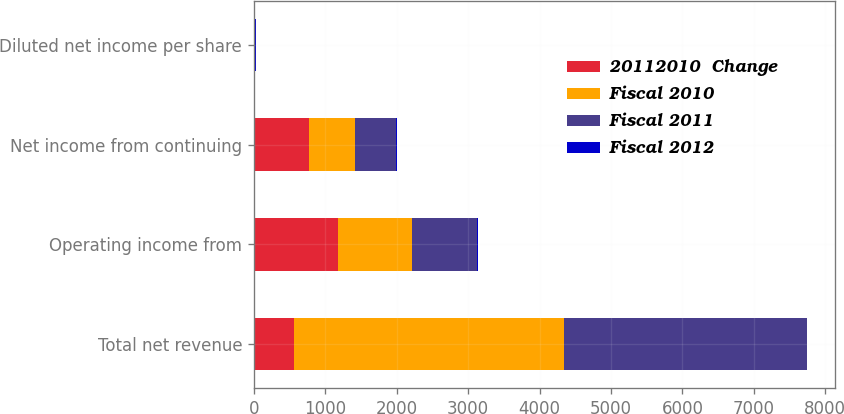Convert chart. <chart><loc_0><loc_0><loc_500><loc_500><stacked_bar_chart><ecel><fcel>Total net revenue<fcel>Operating income from<fcel>Net income from continuing<fcel>Diluted net income per share<nl><fcel>20112010  Change<fcel>564<fcel>1177<fcel>767<fcel>2.52<nl><fcel>Fiscal 2010<fcel>3772<fcel>1037<fcel>652<fcel>2.06<nl><fcel>Fiscal 2011<fcel>3403<fcel>904<fcel>564<fcel>1.74<nl><fcel>Fiscal 2012<fcel>10<fcel>14<fcel>18<fcel>22<nl></chart> 